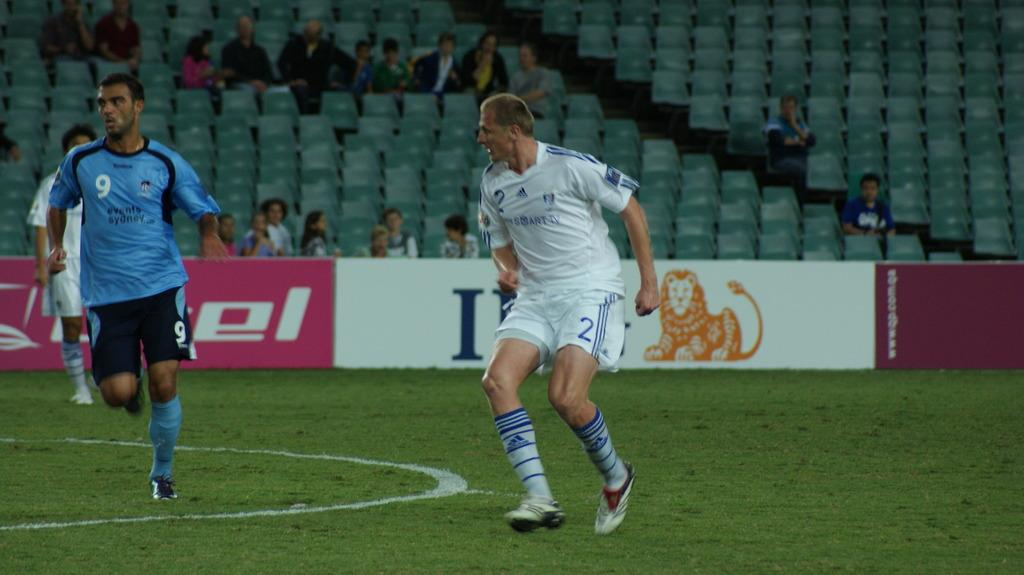<image>
Present a compact description of the photo's key features. A player in a blue events sydney jersey runs down the field 